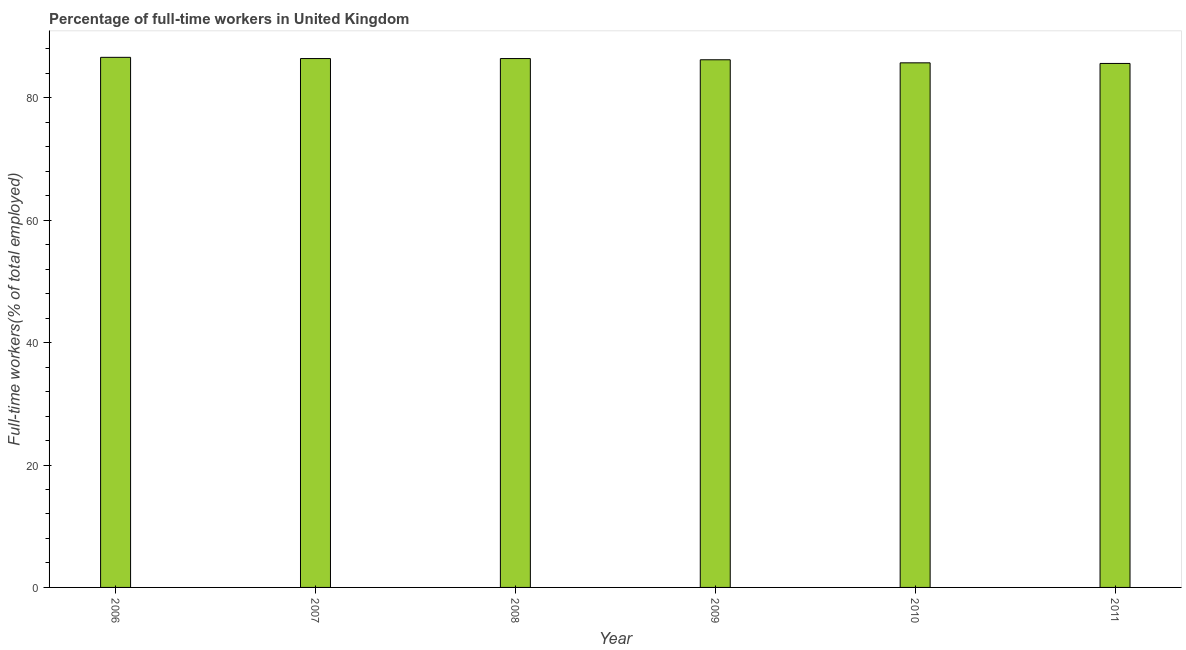Does the graph contain any zero values?
Ensure brevity in your answer.  No. Does the graph contain grids?
Offer a very short reply. No. What is the title of the graph?
Your answer should be compact. Percentage of full-time workers in United Kingdom. What is the label or title of the X-axis?
Keep it short and to the point. Year. What is the label or title of the Y-axis?
Give a very brief answer. Full-time workers(% of total employed). What is the percentage of full-time workers in 2009?
Your answer should be very brief. 86.2. Across all years, what is the maximum percentage of full-time workers?
Give a very brief answer. 86.6. Across all years, what is the minimum percentage of full-time workers?
Your response must be concise. 85.6. In which year was the percentage of full-time workers minimum?
Make the answer very short. 2011. What is the sum of the percentage of full-time workers?
Your response must be concise. 516.9. What is the difference between the percentage of full-time workers in 2008 and 2011?
Keep it short and to the point. 0.8. What is the average percentage of full-time workers per year?
Ensure brevity in your answer.  86.15. What is the median percentage of full-time workers?
Your answer should be compact. 86.3. In how many years, is the percentage of full-time workers greater than 16 %?
Ensure brevity in your answer.  6. Do a majority of the years between 2006 and 2007 (inclusive) have percentage of full-time workers greater than 84 %?
Your answer should be very brief. Yes. What is the ratio of the percentage of full-time workers in 2007 to that in 2010?
Provide a short and direct response. 1.01. Is the difference between the percentage of full-time workers in 2007 and 2009 greater than the difference between any two years?
Keep it short and to the point. No. What is the difference between the highest and the second highest percentage of full-time workers?
Make the answer very short. 0.2. Is the sum of the percentage of full-time workers in 2007 and 2011 greater than the maximum percentage of full-time workers across all years?
Keep it short and to the point. Yes. How many bars are there?
Make the answer very short. 6. How many years are there in the graph?
Ensure brevity in your answer.  6. Are the values on the major ticks of Y-axis written in scientific E-notation?
Make the answer very short. No. What is the Full-time workers(% of total employed) in 2006?
Your answer should be compact. 86.6. What is the Full-time workers(% of total employed) of 2007?
Keep it short and to the point. 86.4. What is the Full-time workers(% of total employed) of 2008?
Your answer should be very brief. 86.4. What is the Full-time workers(% of total employed) in 2009?
Provide a succinct answer. 86.2. What is the Full-time workers(% of total employed) in 2010?
Ensure brevity in your answer.  85.7. What is the Full-time workers(% of total employed) of 2011?
Ensure brevity in your answer.  85.6. What is the difference between the Full-time workers(% of total employed) in 2006 and 2008?
Give a very brief answer. 0.2. What is the difference between the Full-time workers(% of total employed) in 2006 and 2009?
Give a very brief answer. 0.4. What is the difference between the Full-time workers(% of total employed) in 2006 and 2011?
Keep it short and to the point. 1. What is the difference between the Full-time workers(% of total employed) in 2007 and 2008?
Provide a short and direct response. 0. What is the difference between the Full-time workers(% of total employed) in 2007 and 2009?
Provide a short and direct response. 0.2. What is the difference between the Full-time workers(% of total employed) in 2007 and 2011?
Your answer should be compact. 0.8. What is the difference between the Full-time workers(% of total employed) in 2009 and 2010?
Give a very brief answer. 0.5. What is the difference between the Full-time workers(% of total employed) in 2010 and 2011?
Ensure brevity in your answer.  0.1. What is the ratio of the Full-time workers(% of total employed) in 2006 to that in 2007?
Offer a terse response. 1. What is the ratio of the Full-time workers(% of total employed) in 2006 to that in 2008?
Give a very brief answer. 1. What is the ratio of the Full-time workers(% of total employed) in 2007 to that in 2008?
Make the answer very short. 1. What is the ratio of the Full-time workers(% of total employed) in 2007 to that in 2009?
Ensure brevity in your answer.  1. What is the ratio of the Full-time workers(% of total employed) in 2007 to that in 2010?
Provide a short and direct response. 1.01. What is the ratio of the Full-time workers(% of total employed) in 2008 to that in 2010?
Keep it short and to the point. 1.01. What is the ratio of the Full-time workers(% of total employed) in 2008 to that in 2011?
Your answer should be very brief. 1.01. What is the ratio of the Full-time workers(% of total employed) in 2009 to that in 2011?
Make the answer very short. 1.01. What is the ratio of the Full-time workers(% of total employed) in 2010 to that in 2011?
Provide a short and direct response. 1. 